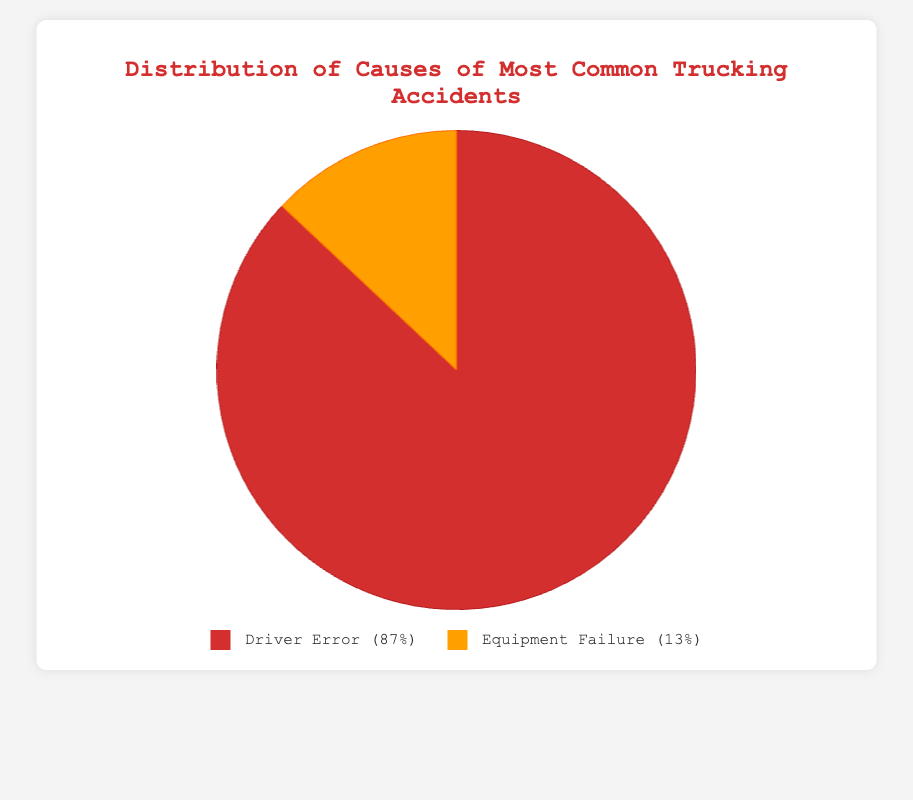what percentage of trucking accidents is caused by driver error? From the pie chart, Driver Error accounts for 87% of the accidents.
Answer: 87% How much higher is the percentage of accidents caused by driver error compared to equipment failure? Driver Error is 87% and Equipment Failure is 13%, so the difference is 87% - 13% = 74%.
Answer: 74% Which category causes the majority of trucking accidents? The pie chart shows that Driver Error is larger than Equipment Failure.
Answer: Driver Error Between brake issues and tired driving, which is a bigger cause of trucking accidents? Fatigue under Driver Error is 33%, while Brake Issues under Equipment Failure is 8%, making Fatigue larger.
Answer: Fatigue If you add up the percentages of fatigue and distracted driving under driver error, what do you get? Fatigue is 33% and Distracted Driving is 18%, so 33% + 18% = 51%.
Answer: 51% What is the combined percentage of accidents caused by brake issues and tire blowouts? Brake Issues is 8% and Tire Blowouts is 3%, so 8% + 3% = 11%.
Answer: 11% Are equipment failures responsible for fewer than 20% of all trucking accidents? The pie chart shows Equipment Failure is 13%, which is less than 20%.
Answer: Yes Which cause of driver error is depicted in a darker color in the legend? The pie chart legend shows that Driver Error is represented by a darker red color.
Answer: Driver Error How does the percentage of tire blowouts compare to engine malfunctions? Tire Blowouts are at 3% and Engine Malfunctions at 2%, so Tire Blowouts are higher by 1%.
Answer: Tire Blowouts by 1% 